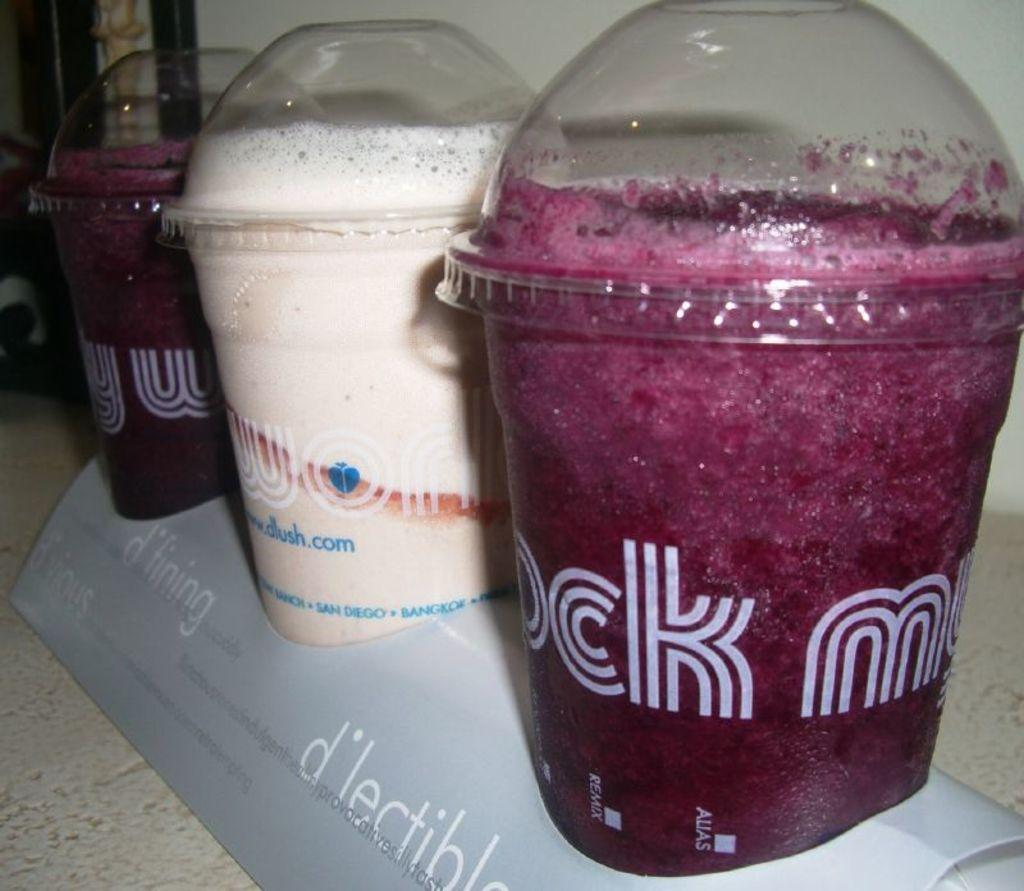<image>
Create a compact narrative representing the image presented. Three tubs of liquid drunks, the latter of which has the letters CK and M visible. 